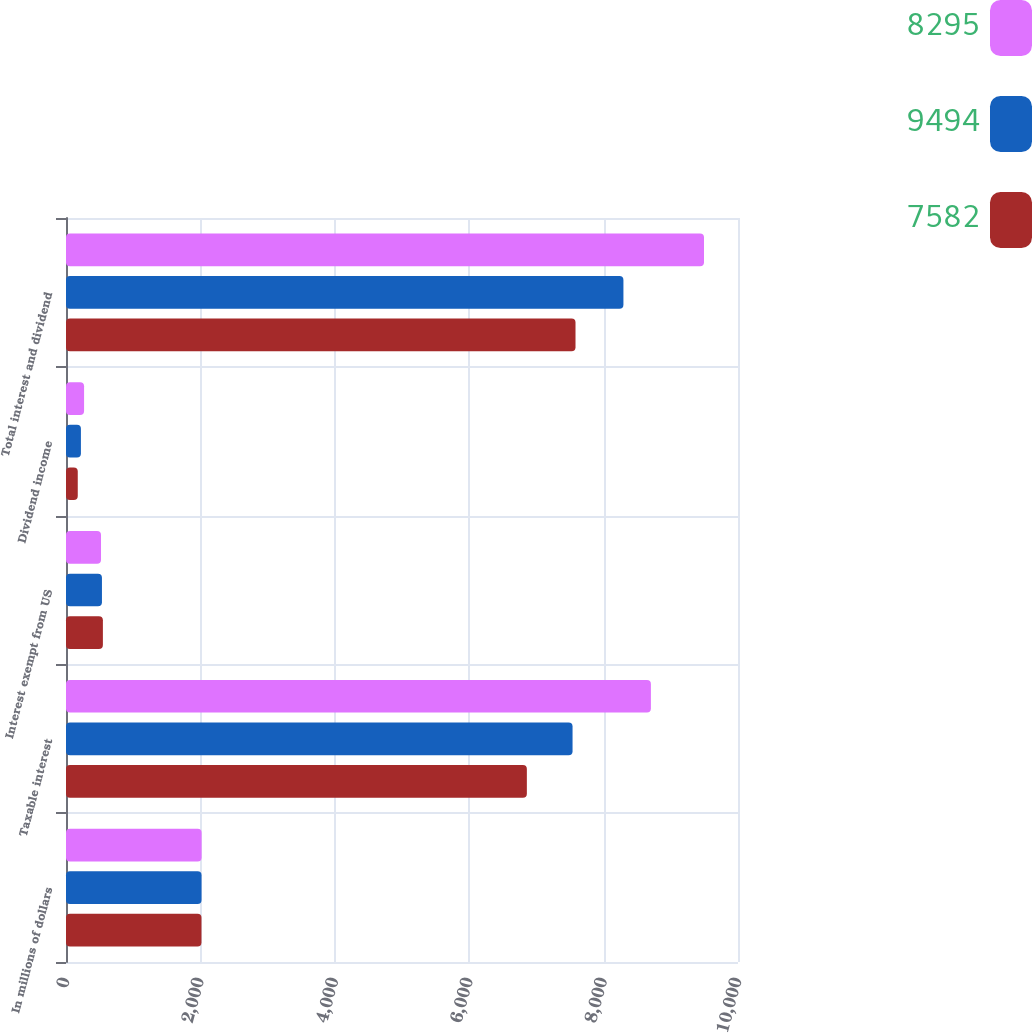Convert chart to OTSL. <chart><loc_0><loc_0><loc_500><loc_500><stacked_bar_chart><ecel><fcel>In millions of dollars<fcel>Taxable interest<fcel>Interest exempt from US<fcel>Dividend income<fcel>Total interest and dividend<nl><fcel>8295<fcel>2018<fcel>8704<fcel>521<fcel>269<fcel>9494<nl><fcel>9494<fcel>2017<fcel>7538<fcel>535<fcel>222<fcel>8295<nl><fcel>7582<fcel>2016<fcel>6858<fcel>549<fcel>175<fcel>7582<nl></chart> 